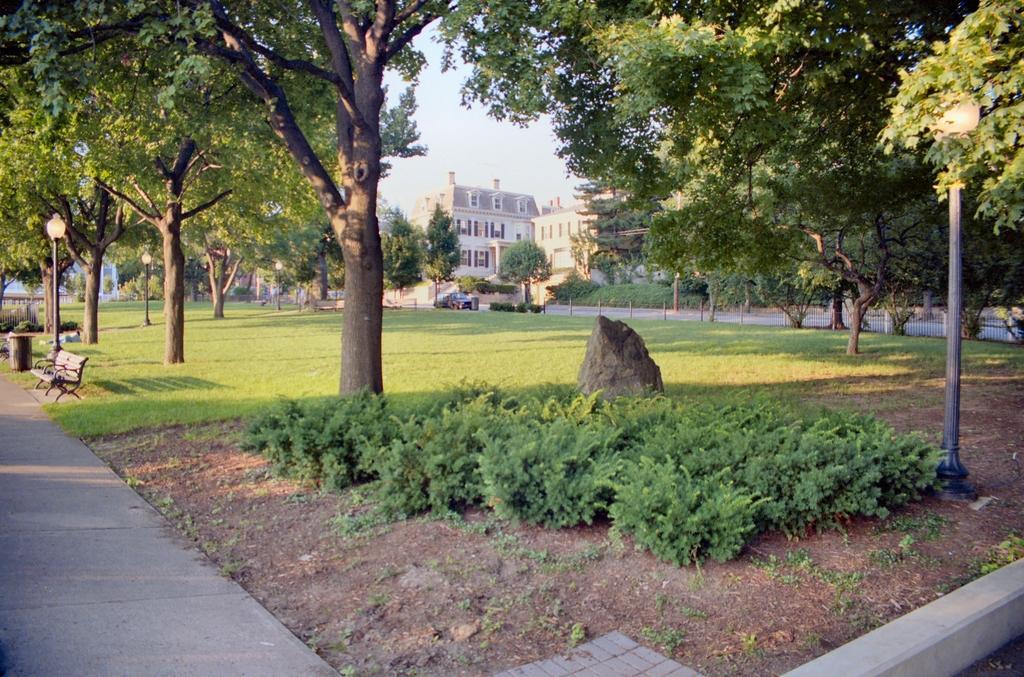Can you describe this image briefly? In this image there are trees and buildings. There is a fence. On the left we can see a bench and a bin. In the background there is sky. At the bottom there are plants and we can see a rock. There is a car. 